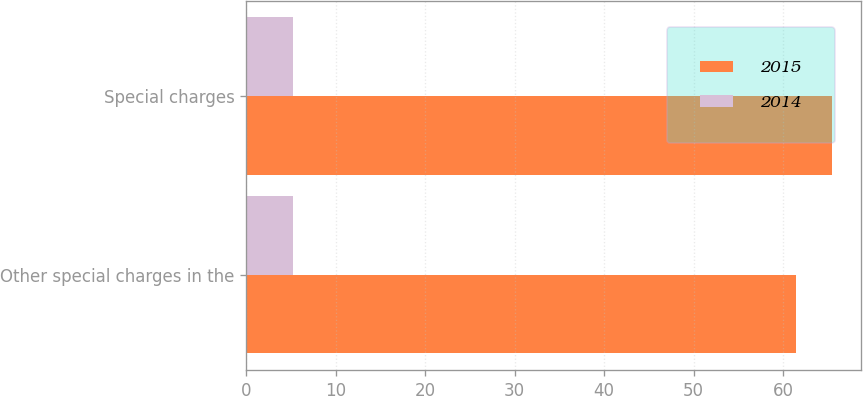Convert chart to OTSL. <chart><loc_0><loc_0><loc_500><loc_500><stacked_bar_chart><ecel><fcel>Other special charges in the<fcel>Special charges<nl><fcel>2015<fcel>61.5<fcel>65.5<nl><fcel>2014<fcel>5.2<fcel>5.2<nl></chart> 